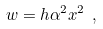Convert formula to latex. <formula><loc_0><loc_0><loc_500><loc_500>w = h \alpha ^ { 2 } x ^ { 2 } \ ,</formula> 